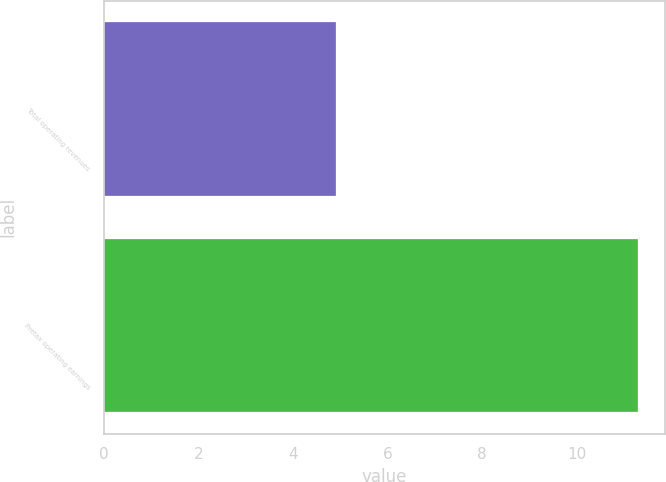<chart> <loc_0><loc_0><loc_500><loc_500><bar_chart><fcel>Total operating revenues<fcel>Pretax operating earnings<nl><fcel>4.9<fcel>11.3<nl></chart> 